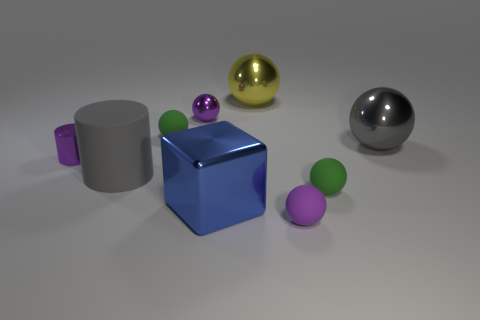How many other objects are the same color as the large matte object?
Your response must be concise. 1. There is a purple ball on the right side of the yellow object; is it the same size as the purple thing that is behind the big gray shiny sphere?
Provide a succinct answer. Yes. The small matte object to the left of the large yellow ball is what color?
Provide a short and direct response. Green. Is the number of blue metal objects behind the small metallic ball less than the number of big yellow metallic balls?
Offer a terse response. Yes. Are the tiny cylinder and the large cylinder made of the same material?
Your response must be concise. No. The yellow thing that is the same shape as the purple matte object is what size?
Offer a very short reply. Large. What number of things are either large balls to the right of the yellow metallic sphere or large metal objects behind the large rubber thing?
Your answer should be compact. 2. Is the number of small things less than the number of things?
Ensure brevity in your answer.  Yes. There is a metallic cylinder; is its size the same as the gray thing that is in front of the purple cylinder?
Your answer should be compact. No. How many shiny things are blue things or big gray things?
Offer a terse response. 2. 